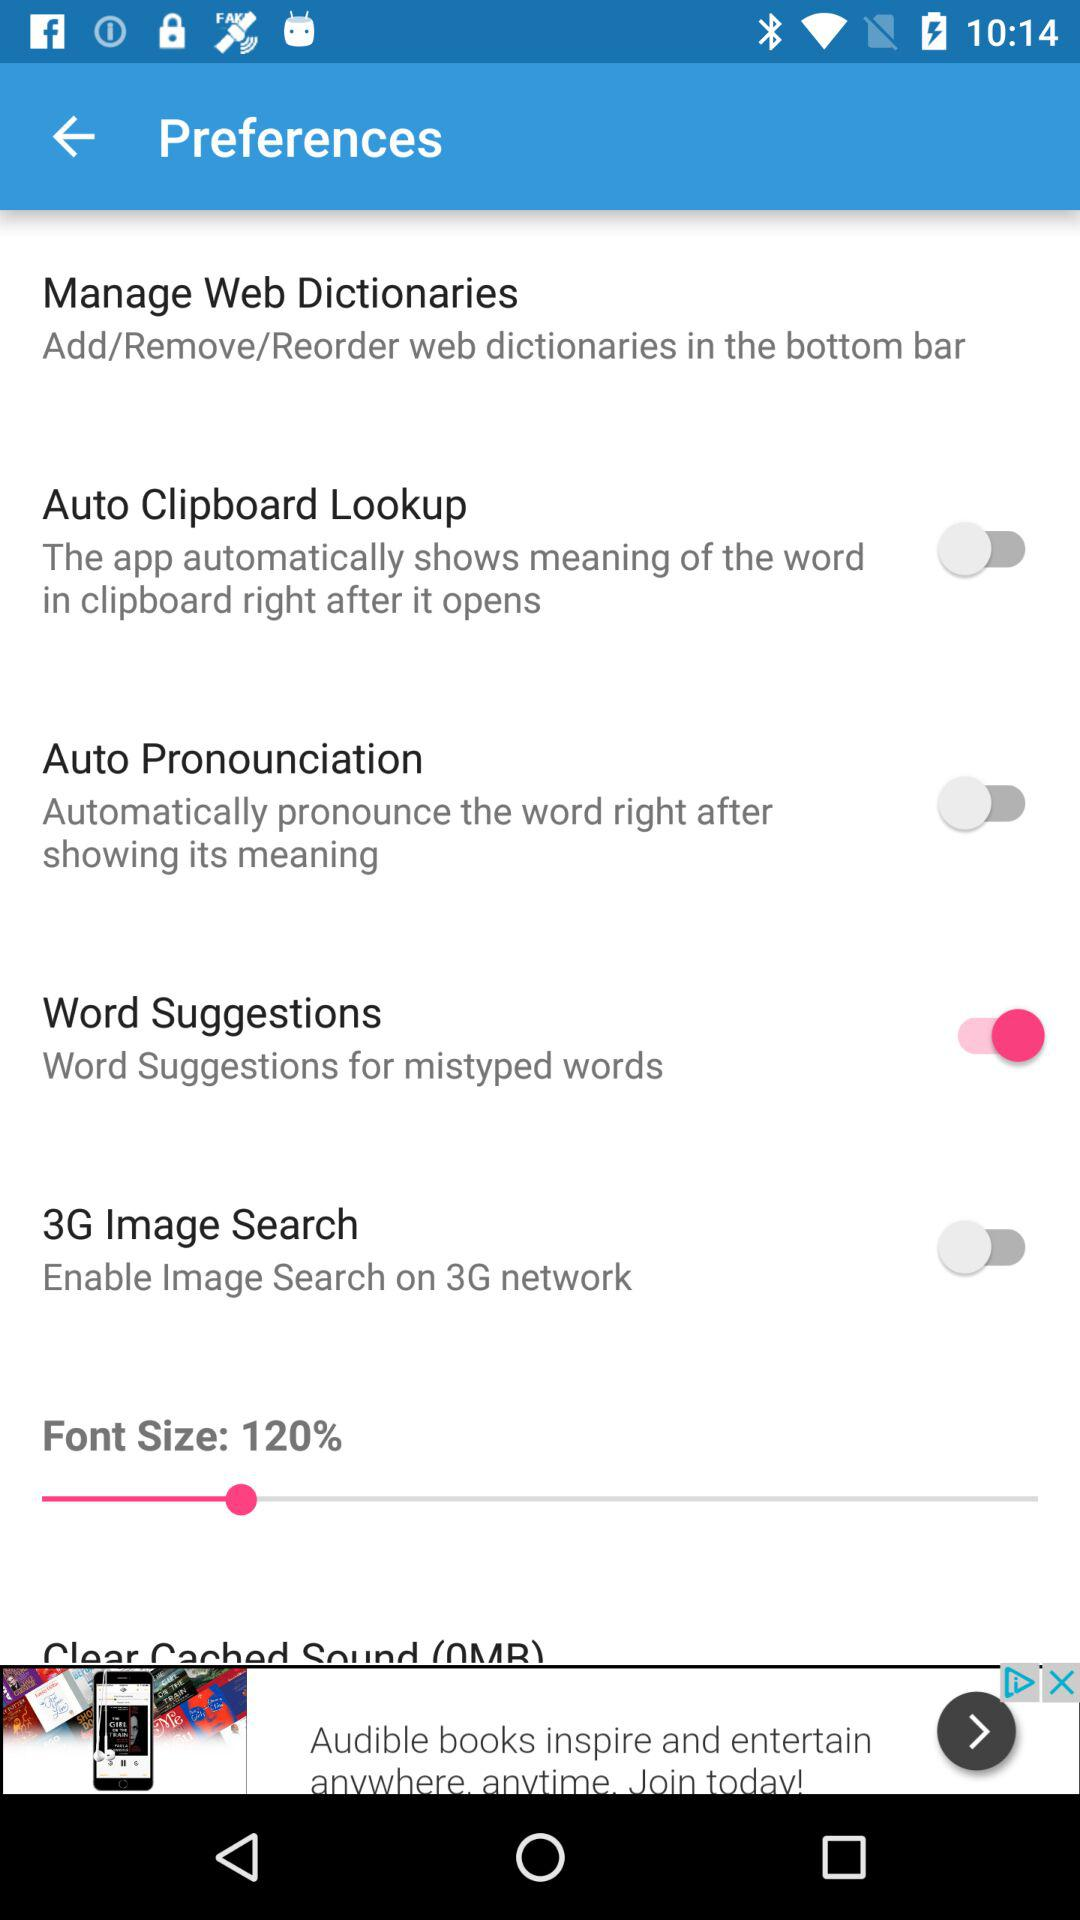Which settings are disabled? The settings that are disabled are "Auto Clipboard Lookup", "Auto Pronounciation" and "3G Image Search". 